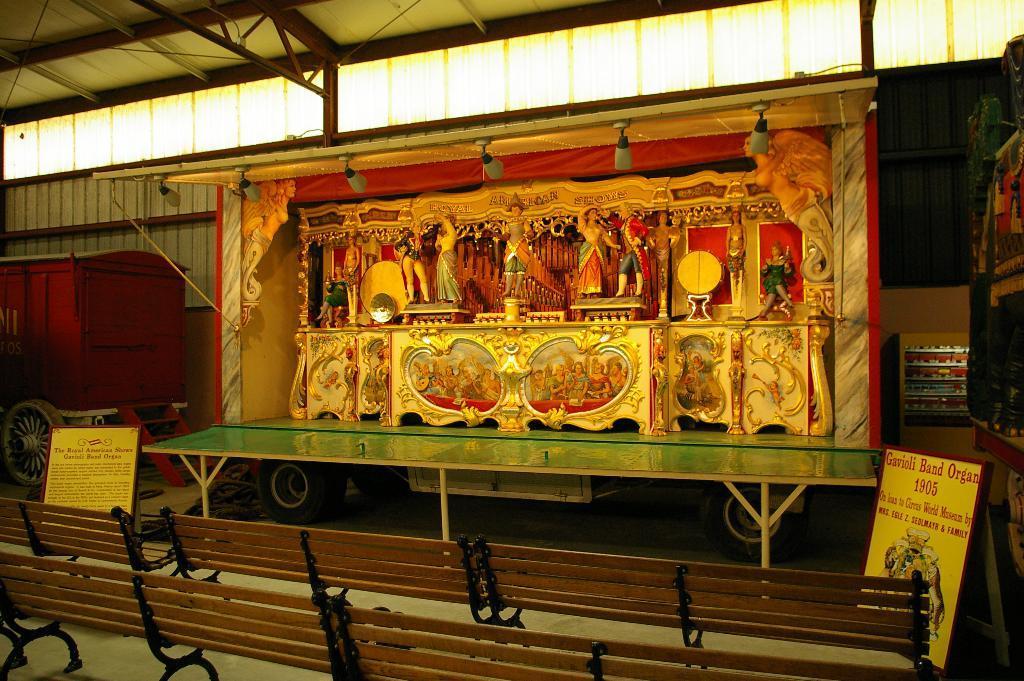Describe this image in one or two sentences. This picture is inside view of a room. In the center of the image a table is there. On the table we can see lights, sculptures, frames are there. On the left side of the image a truck is there. At the bottom of the image we can see benches, boards, floor are there. At the top of the image roof is present. 